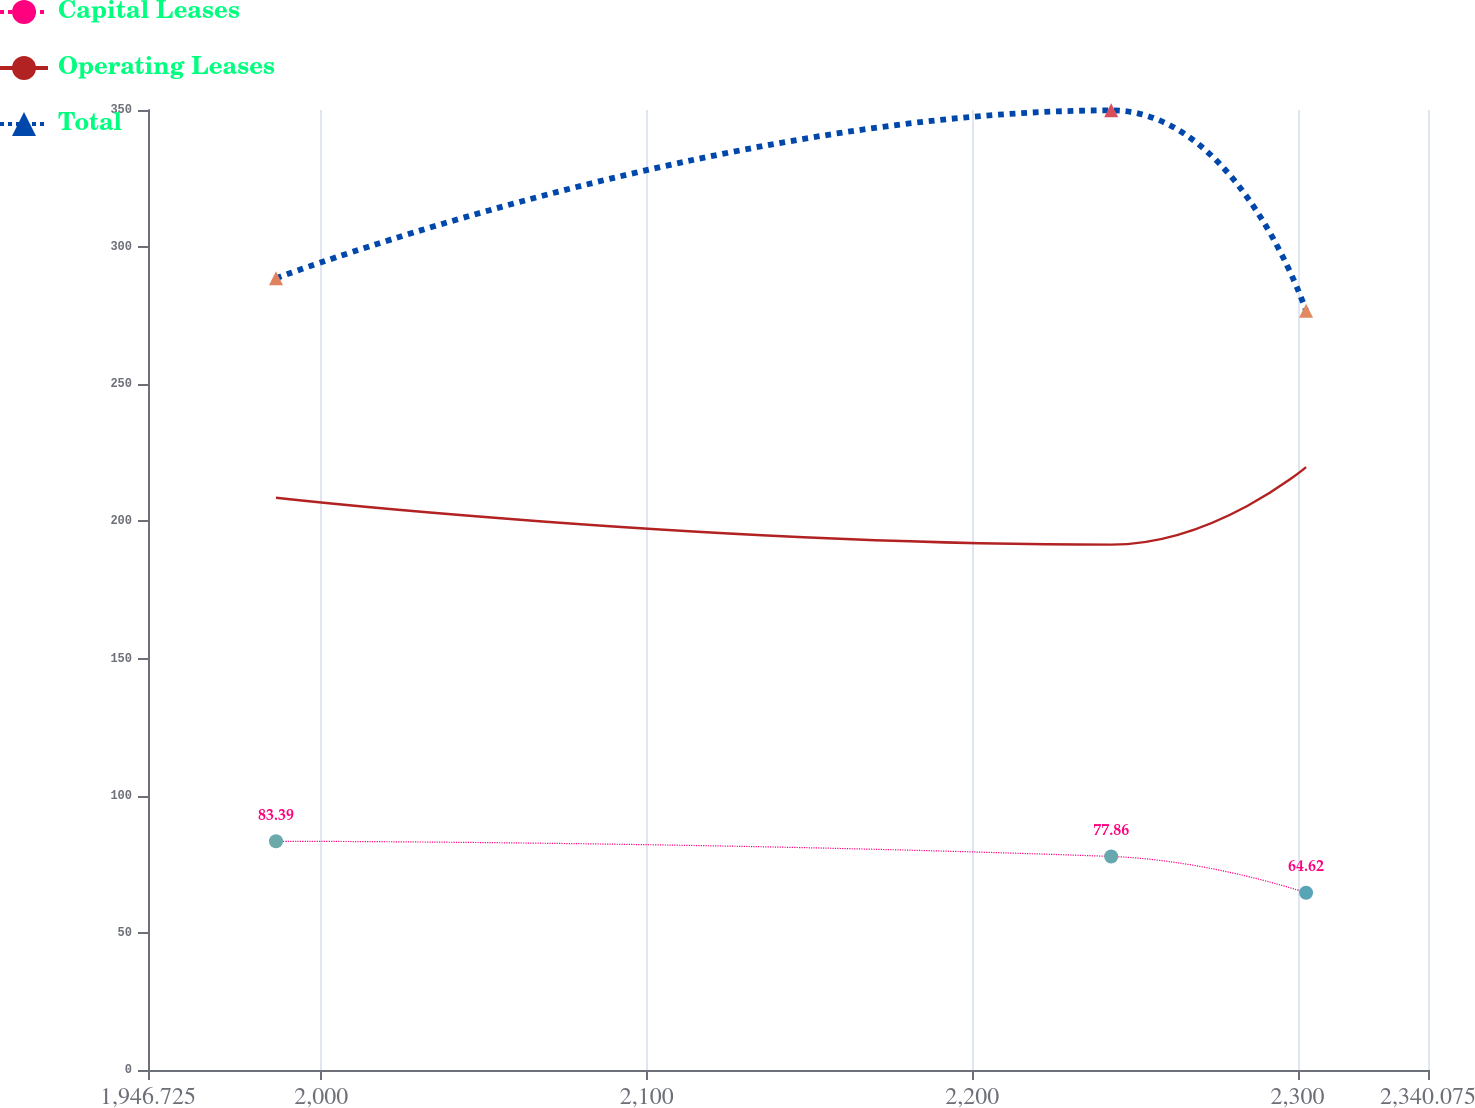Convert chart. <chart><loc_0><loc_0><loc_500><loc_500><line_chart><ecel><fcel>Capital Leases<fcel>Operating Leases<fcel>Total<nl><fcel>1986.06<fcel>83.39<fcel>208.61<fcel>288.65<nl><fcel>2242.71<fcel>77.86<fcel>191.54<fcel>349.87<nl><fcel>2302.61<fcel>64.62<fcel>219.79<fcel>276.78<nl><fcel>2341.01<fcel>80.84<fcel>234.01<fcel>264.91<nl><fcel>2379.41<fcel>57.18<fcel>172.92<fcel>231.21<nl></chart> 